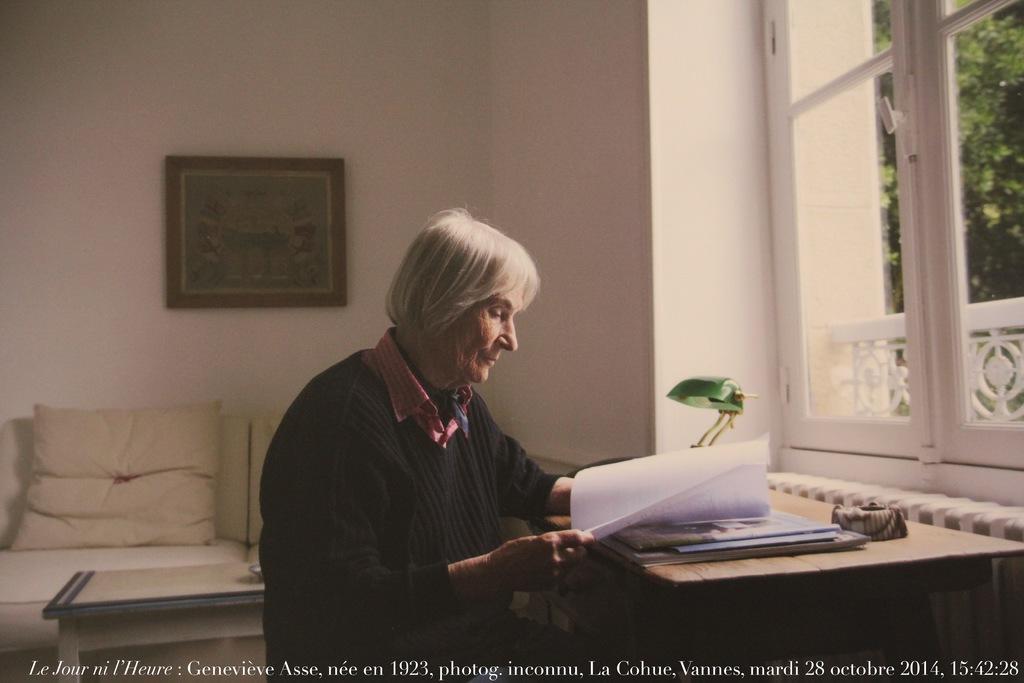How would you summarize this image in a sentence or two? In this image I can see a woman and she is holding a paper in her hand. On this table I can see a lamp. In the background I can see a frame on this wall. 